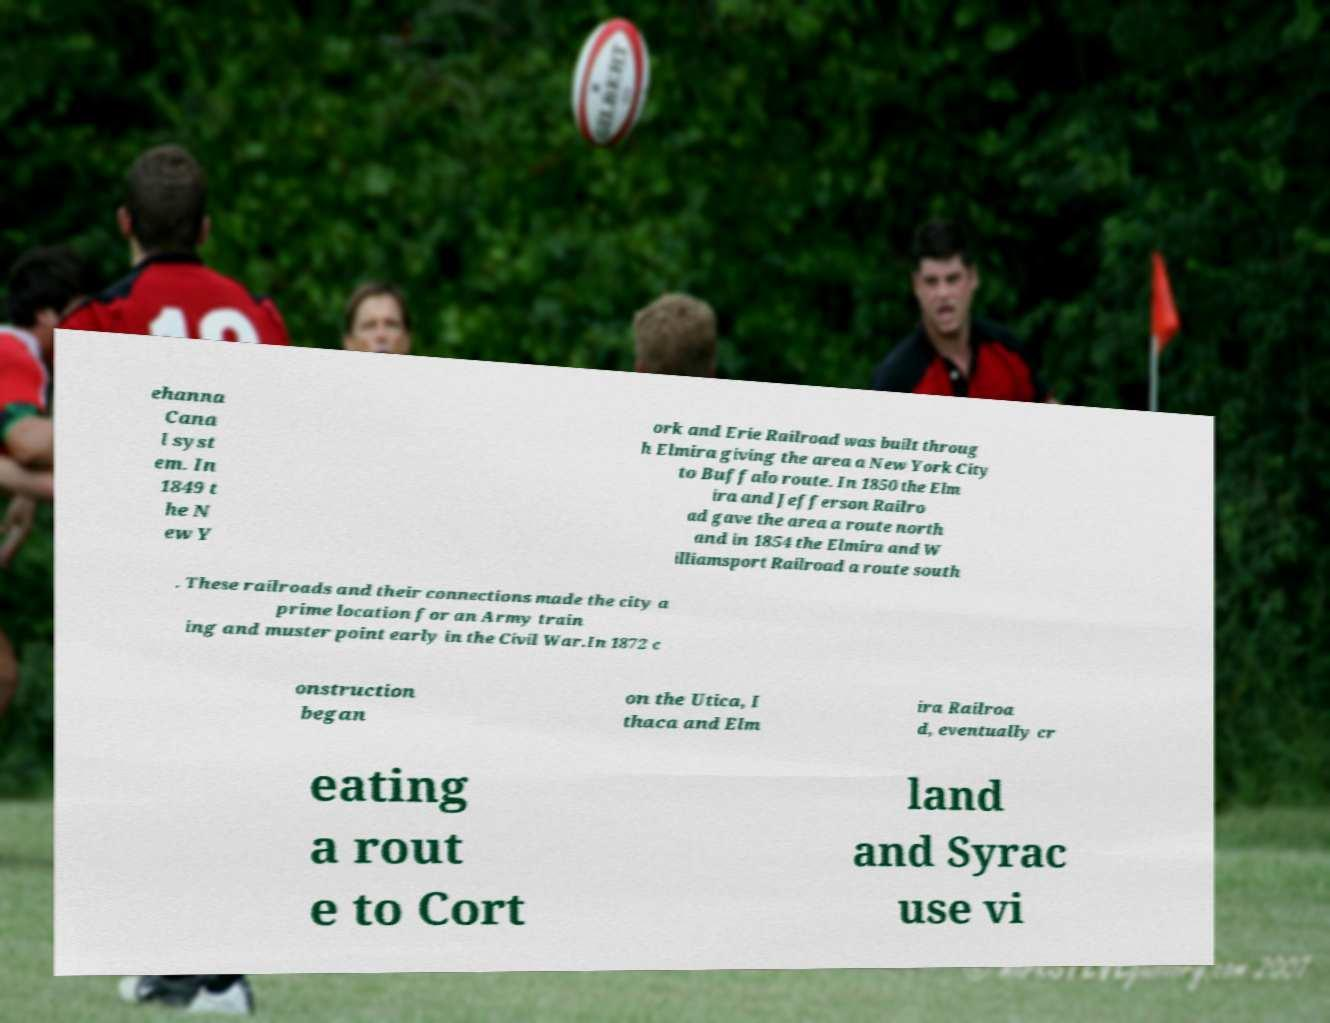What messages or text are displayed in this image? I need them in a readable, typed format. ehanna Cana l syst em. In 1849 t he N ew Y ork and Erie Railroad was built throug h Elmira giving the area a New York City to Buffalo route. In 1850 the Elm ira and Jefferson Railro ad gave the area a route north and in 1854 the Elmira and W illiamsport Railroad a route south . These railroads and their connections made the city a prime location for an Army train ing and muster point early in the Civil War.In 1872 c onstruction began on the Utica, I thaca and Elm ira Railroa d, eventually cr eating a rout e to Cort land and Syrac use vi 